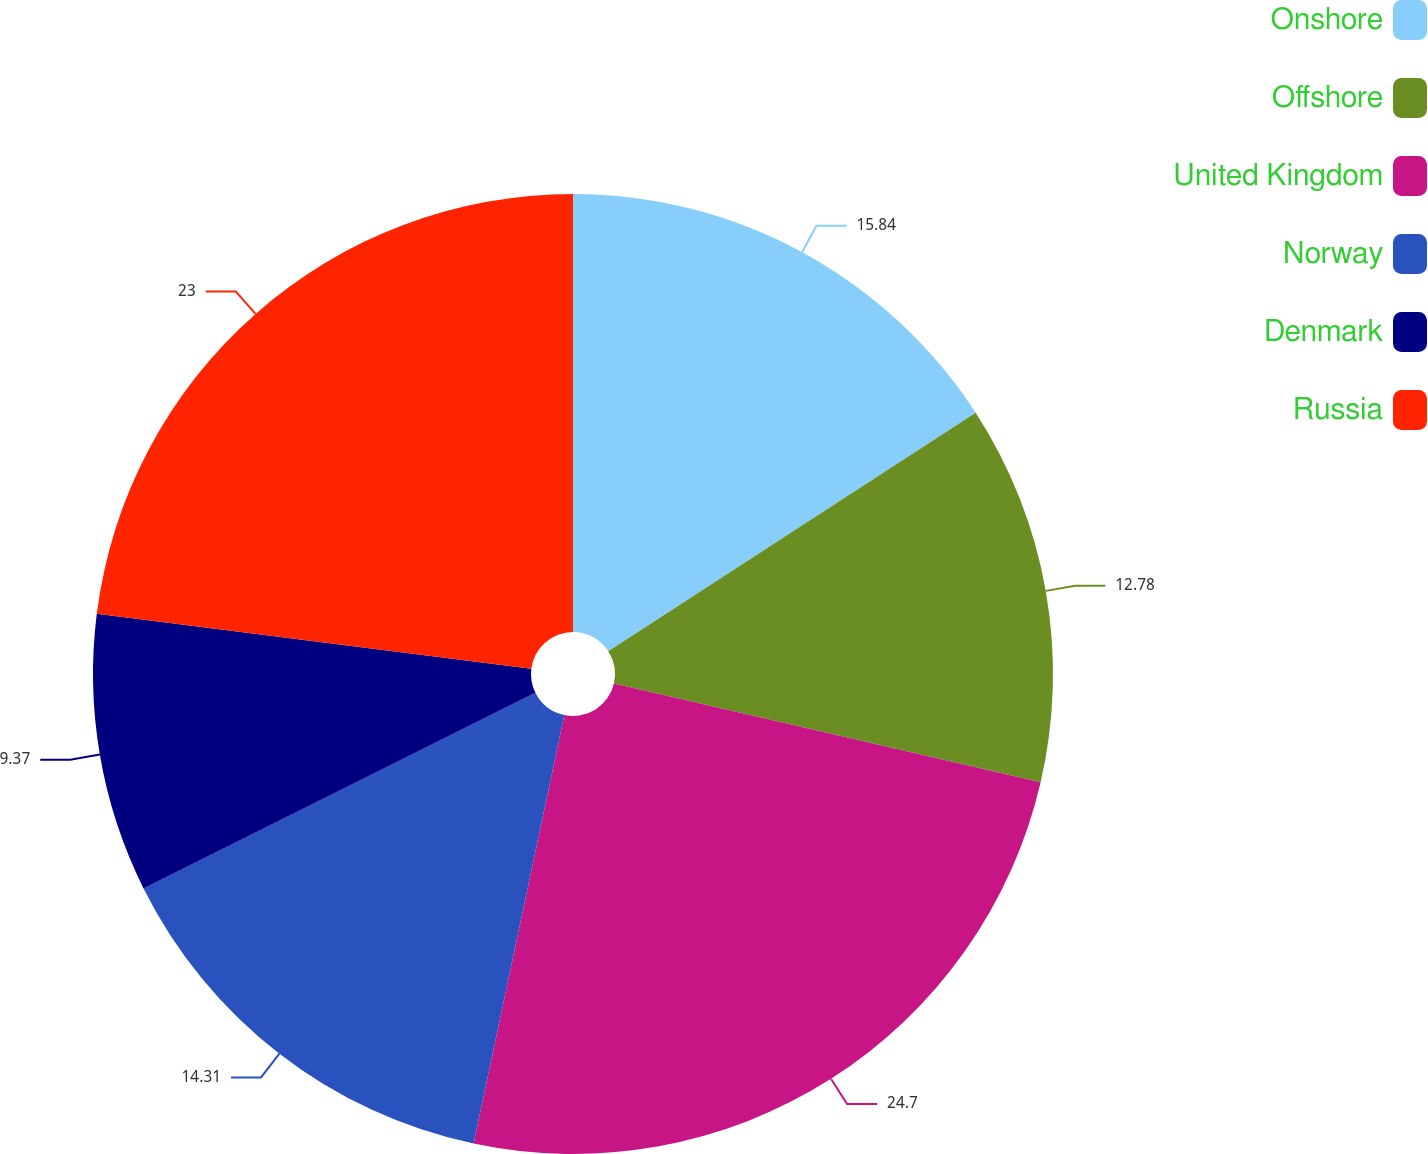<chart> <loc_0><loc_0><loc_500><loc_500><pie_chart><fcel>Onshore<fcel>Offshore<fcel>United Kingdom<fcel>Norway<fcel>Denmark<fcel>Russia<nl><fcel>15.84%<fcel>12.78%<fcel>24.7%<fcel>14.31%<fcel>9.37%<fcel>23.0%<nl></chart> 